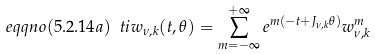<formula> <loc_0><loc_0><loc_500><loc_500>\ e q q n o ( 5 . 2 . 1 4 a ) \ t i w _ { \nu , k } ( t , \theta ) = \sum _ { m = - \infty } ^ { + \infty } e ^ { m ( - t + J _ { \nu , k } \theta ) } w ^ { m } _ { \nu , k }</formula> 